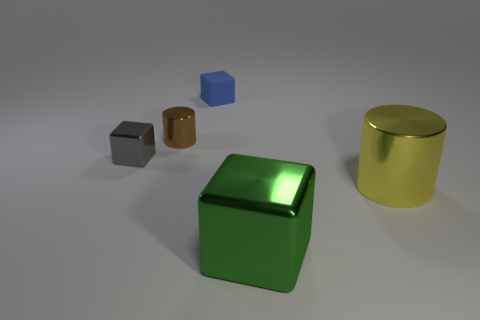There is a cylinder that is to the left of the large green thing; what is its material?
Provide a short and direct response. Metal. Do the yellow cylinder and the blue cube have the same size?
Ensure brevity in your answer.  No. Is the number of brown shiny cylinders behind the small blue object greater than the number of tiny cubes?
Make the answer very short. No. There is a yellow object that is the same material as the small brown cylinder; what size is it?
Offer a very short reply. Large. Are there any tiny brown cylinders to the right of the yellow cylinder?
Ensure brevity in your answer.  No. Does the gray object have the same shape as the yellow thing?
Your answer should be very brief. No. How big is the gray thing that is in front of the metal cylinder that is behind the large object behind the green metallic cube?
Provide a short and direct response. Small. What material is the small cylinder?
Give a very brief answer. Metal. Do the large yellow thing and the shiny thing to the left of the brown object have the same shape?
Provide a short and direct response. No. The big object behind the big metallic thing that is in front of the big yellow shiny thing that is on the right side of the tiny rubber object is made of what material?
Provide a succinct answer. Metal. 